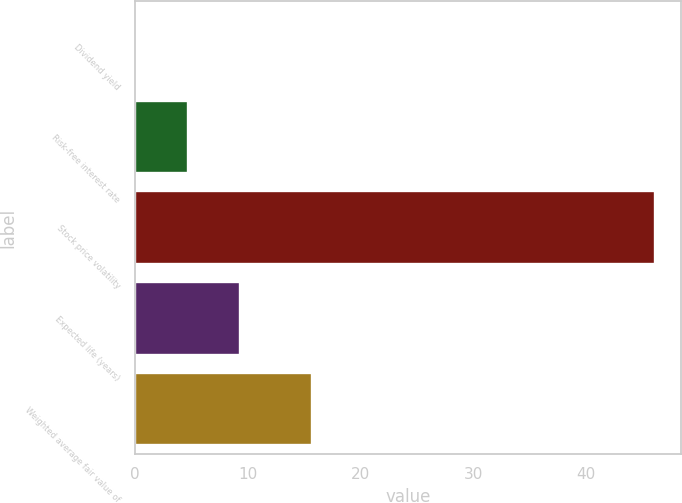Convert chart. <chart><loc_0><loc_0><loc_500><loc_500><bar_chart><fcel>Dividend yield<fcel>Risk-free interest rate<fcel>Stock price volatility<fcel>Expected life (years)<fcel>Weighted average fair value of<nl><fcel>0.1<fcel>4.7<fcel>46.1<fcel>9.3<fcel>15.69<nl></chart> 